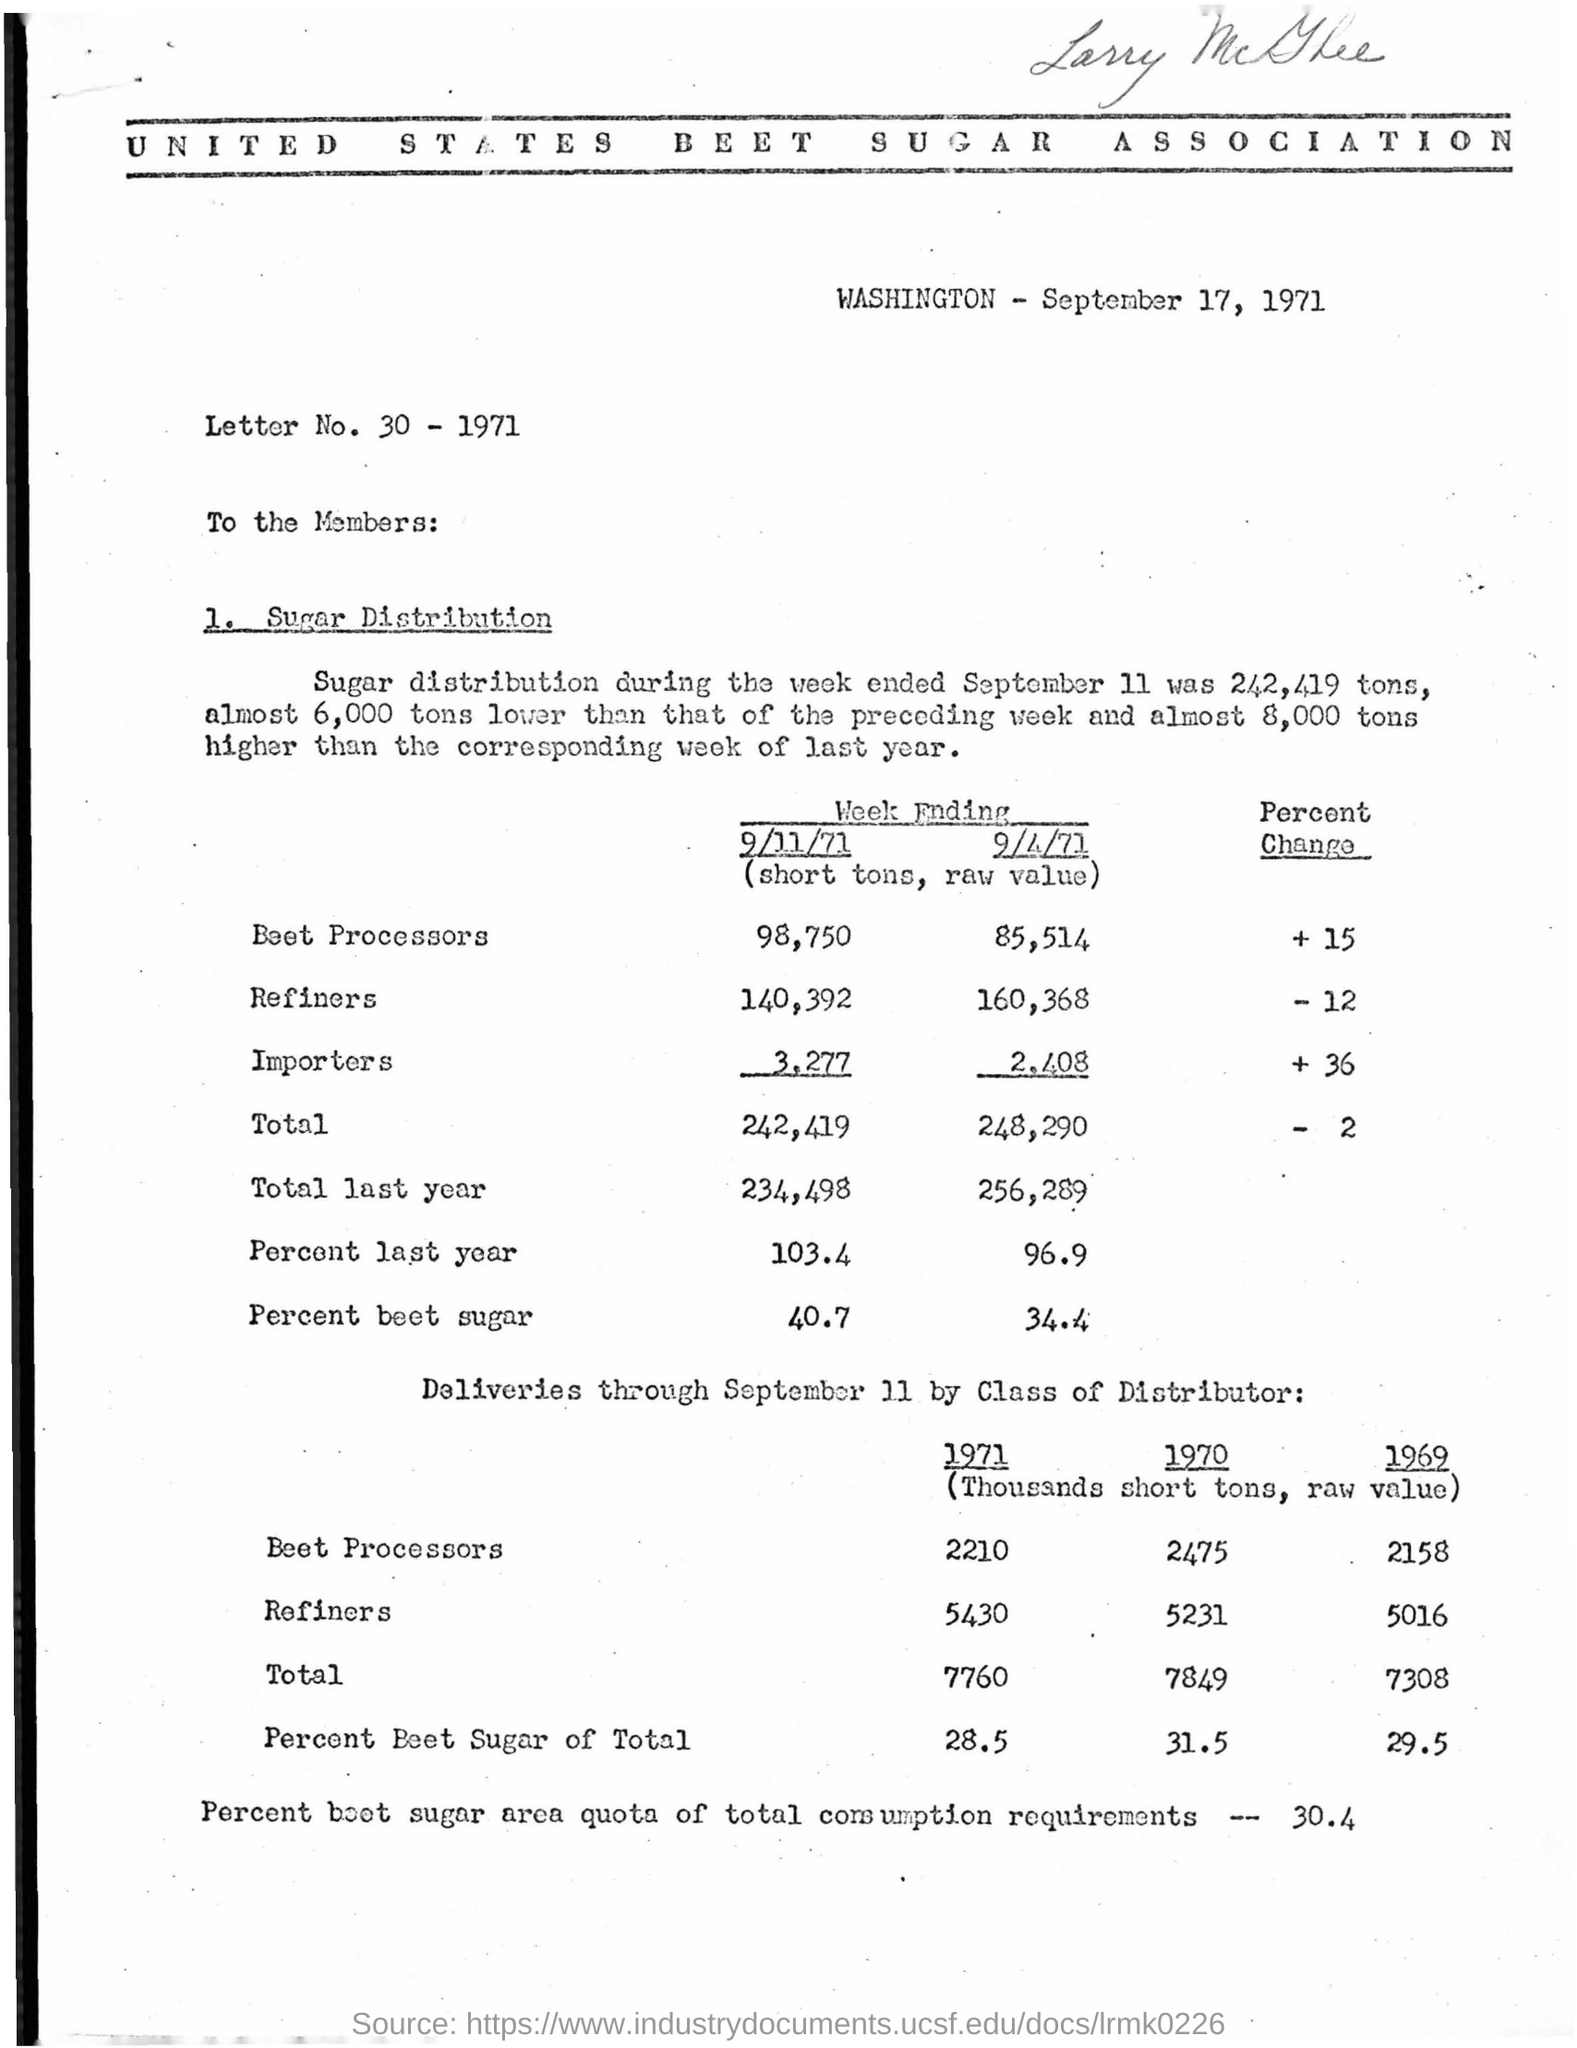What is the letter number? The question seems to be asking for a specific identifying number of the letter, which is not clearly discernible in the image provided. However, the document is a letter from the United States Beet Sugar Association, and it is dated September 17, 1971. The referenced 'Letter No. 30 - 1971' could potentially be the identifying number of the letter. 